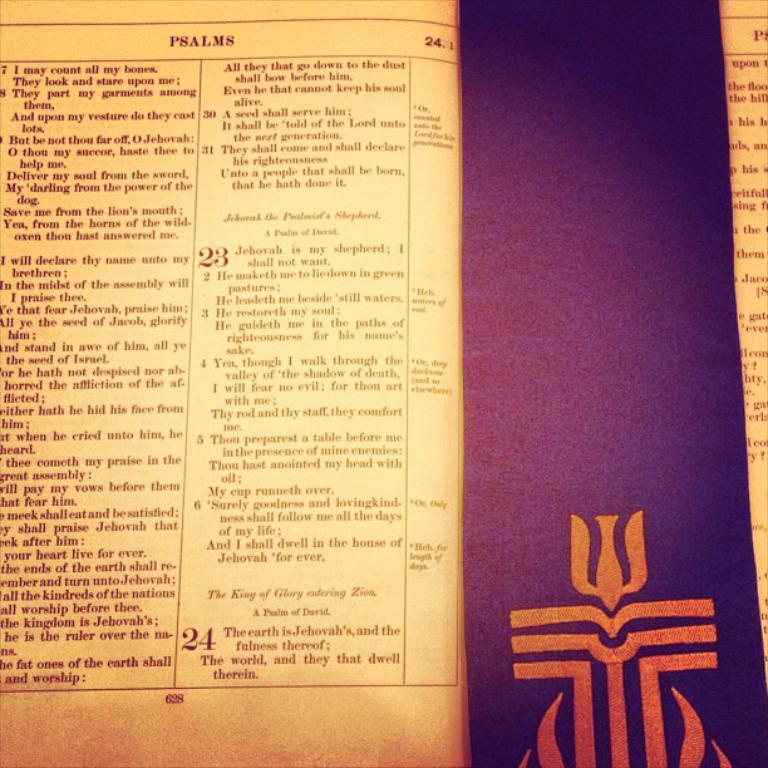Are these psalms?
Keep it short and to the point. Yes. 